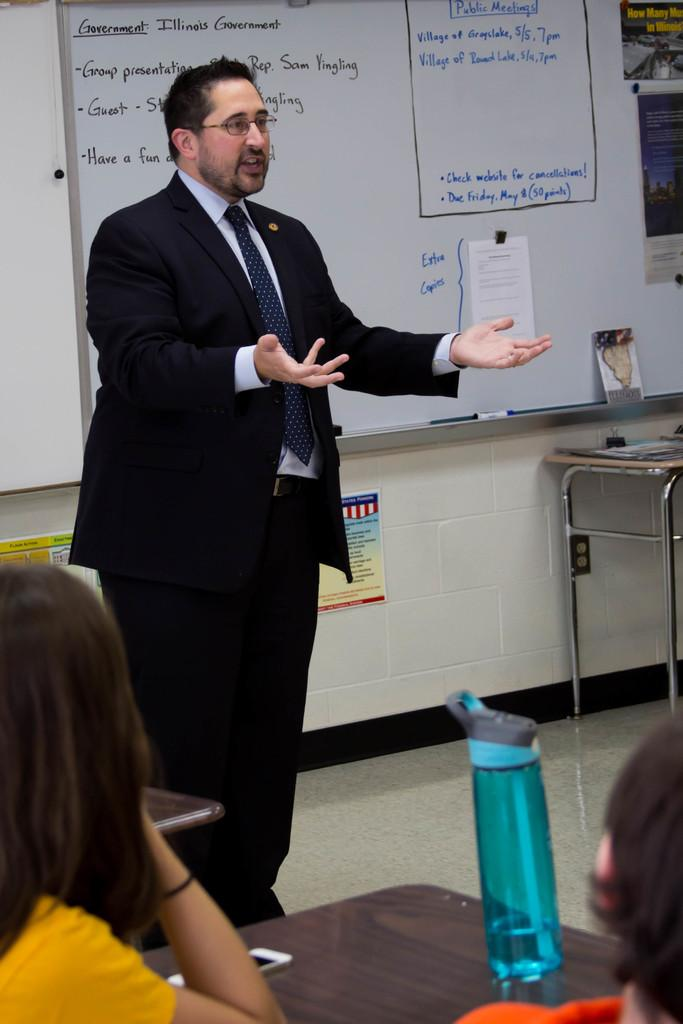<image>
Describe the image concisely. A man speaks in a classroom in front of a whiteboard that has information related to governments on it. 